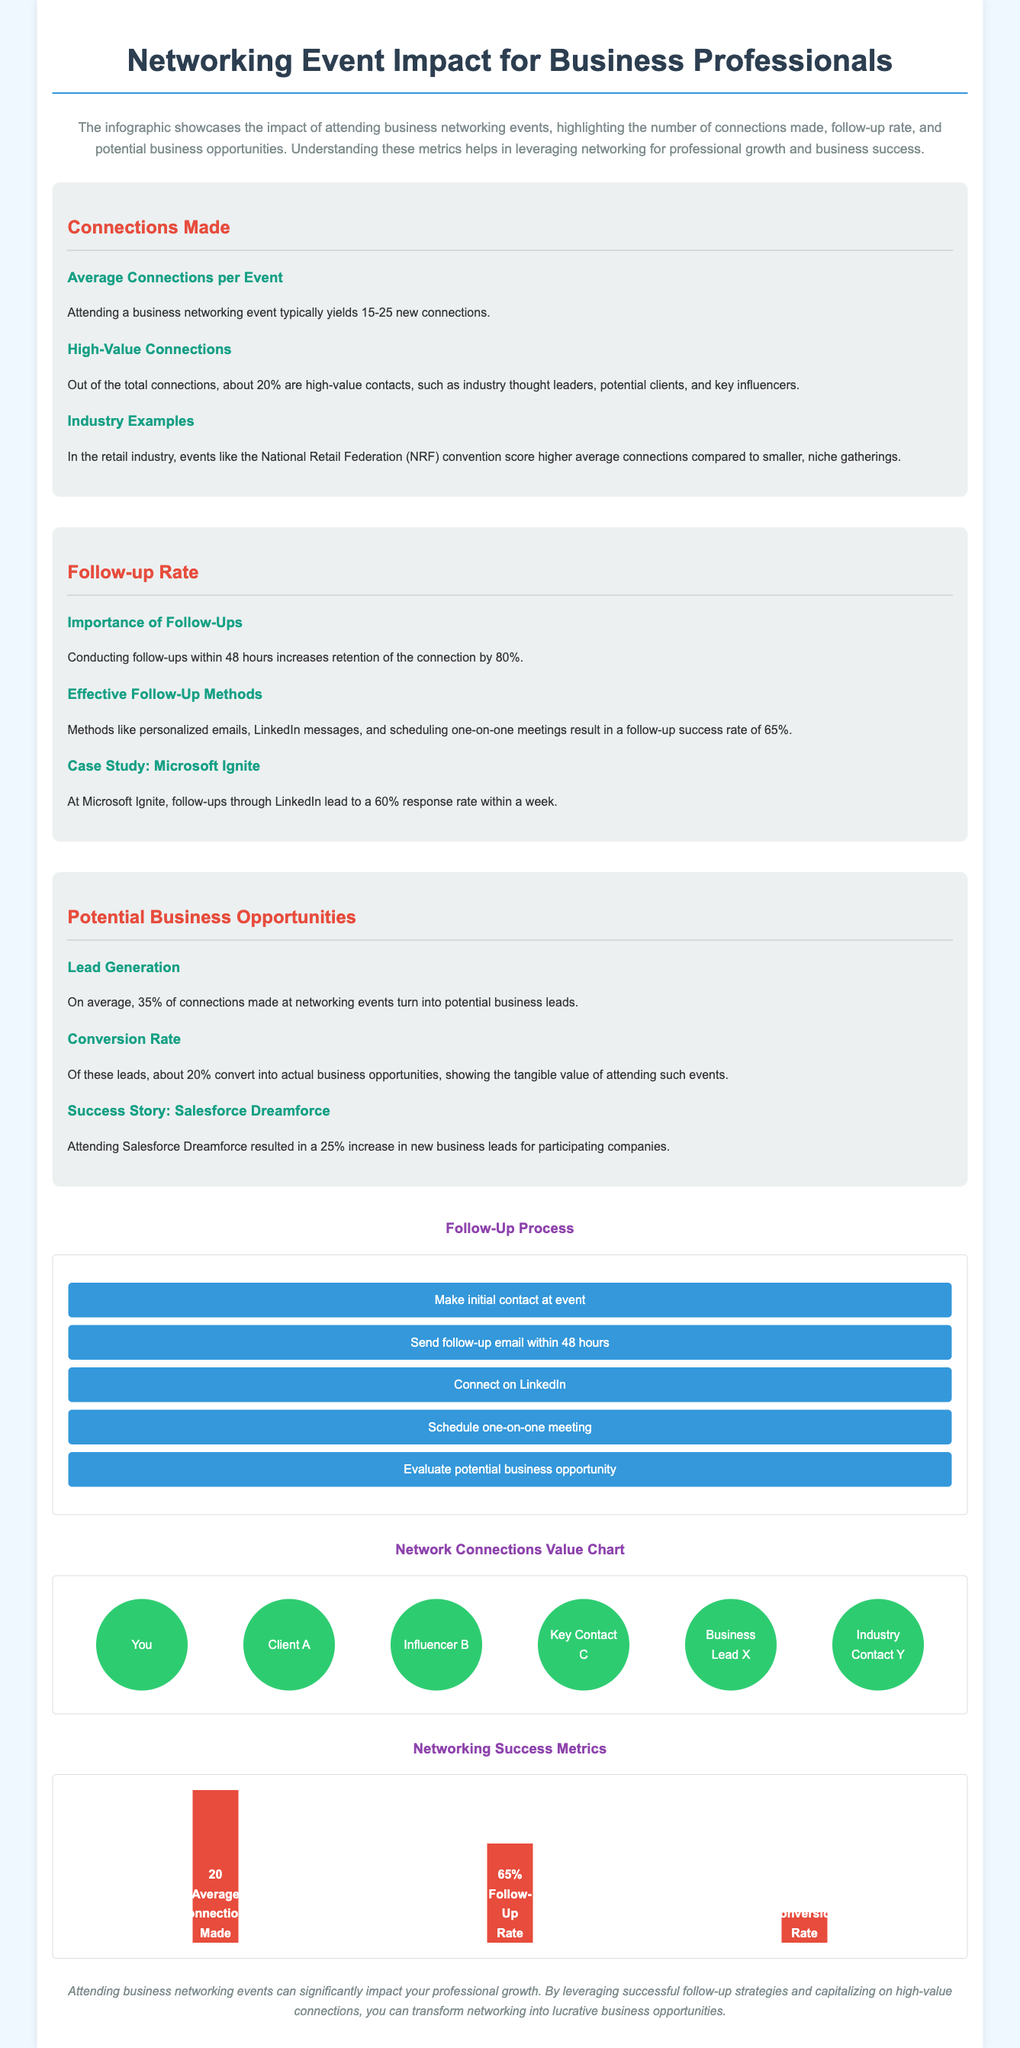what is the average number of connections made per event? The document states that attending a business networking event typically yields 15-25 new connections, making the average 20.
Answer: 20 what percentage of connections are considered high-value? The document mentions that about 20% of the total connections are high-value contacts.
Answer: 20% what is the follow-up success rate using effective methods? Effective follow-up methods result in a follow-up success rate of 65%.
Answer: 65% how many new business leads can be generated on average from connections made? On average, 35% of connections turn into potential business leads, indicating a significant generation of new leads.
Answer: 35% what is the follow-up rate after 48 hours for retaining connections? Conducting follow-ups within 48 hours increases retention of the connection by 80%.
Answer: 80% how much increase in new business leads did Salesforce Dreamforce attendees experience? Attending Salesforce Dreamforce resulted in a 25% increase in new business leads.
Answer: 25% what are the two effective follow-up methods mentioned? The document lists personalized emails and LinkedIn messages as effective follow-up methods.
Answer: personalized emails, LinkedIn messages what visual representation shows the follow-up process? A flowchart illustrates the follow-up process.
Answer: flowchart which networking event is referenced as having a high follow-up response rate? Microsoft Ignite is referenced for having a high follow-up response rate of 60% within a week.
Answer: Microsoft Ignite 